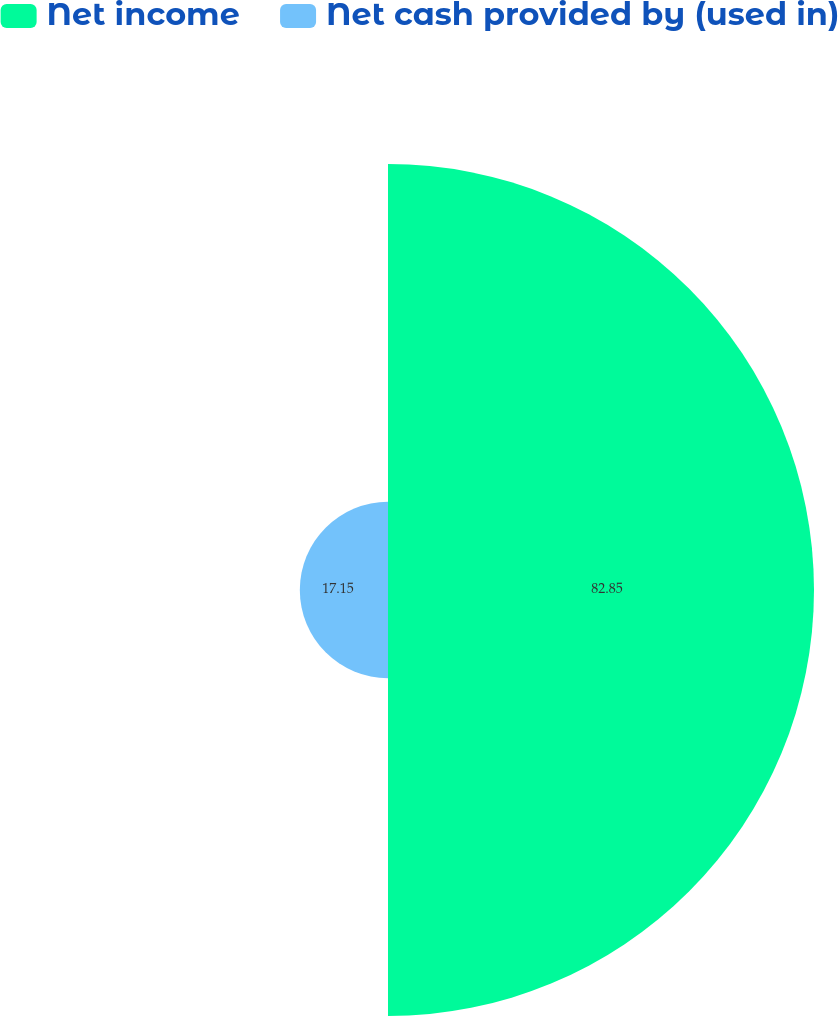Convert chart to OTSL. <chart><loc_0><loc_0><loc_500><loc_500><pie_chart><fcel>Net income<fcel>Net cash provided by (used in)<nl><fcel>82.85%<fcel>17.15%<nl></chart> 